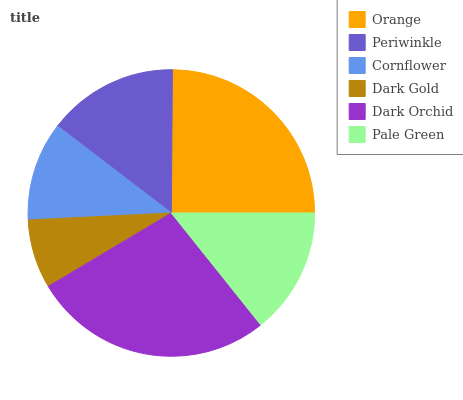Is Dark Gold the minimum?
Answer yes or no. Yes. Is Dark Orchid the maximum?
Answer yes or no. Yes. Is Periwinkle the minimum?
Answer yes or no. No. Is Periwinkle the maximum?
Answer yes or no. No. Is Orange greater than Periwinkle?
Answer yes or no. Yes. Is Periwinkle less than Orange?
Answer yes or no. Yes. Is Periwinkle greater than Orange?
Answer yes or no. No. Is Orange less than Periwinkle?
Answer yes or no. No. Is Periwinkle the high median?
Answer yes or no. Yes. Is Pale Green the low median?
Answer yes or no. Yes. Is Dark Orchid the high median?
Answer yes or no. No. Is Orange the low median?
Answer yes or no. No. 